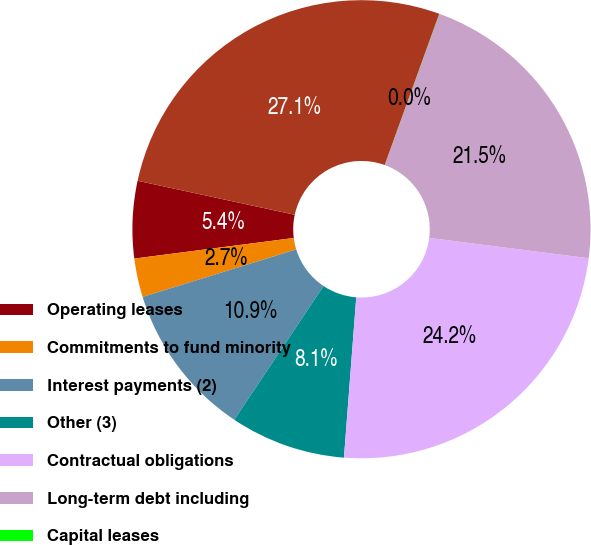Convert chart to OTSL. <chart><loc_0><loc_0><loc_500><loc_500><pie_chart><fcel>Operating leases<fcel>Commitments to fund minority<fcel>Interest payments (2)<fcel>Other (3)<fcel>Contractual obligations<fcel>Long-term debt including<fcel>Capital leases<fcel>TOTAL CONTRACTUAL OBLIGATIONS<nl><fcel>5.44%<fcel>2.73%<fcel>10.86%<fcel>8.15%<fcel>24.2%<fcel>21.49%<fcel>0.02%<fcel>27.12%<nl></chart> 